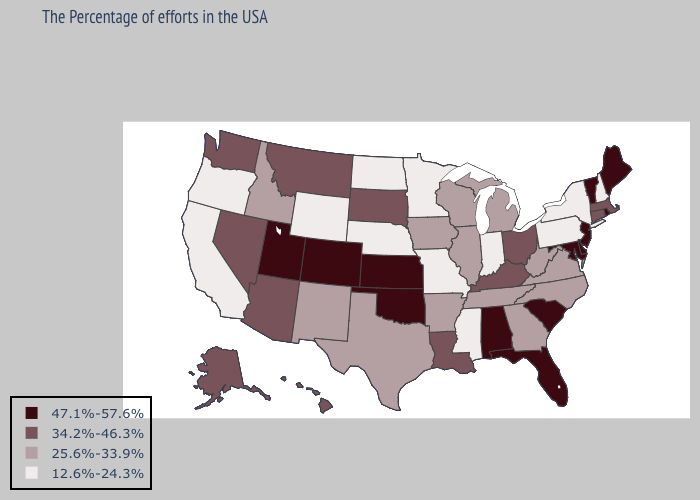Is the legend a continuous bar?
Write a very short answer. No. Does the map have missing data?
Give a very brief answer. No. Does Iowa have a higher value than Indiana?
Short answer required. Yes. Does Hawaii have a higher value than Missouri?
Short answer required. Yes. Which states hav the highest value in the Northeast?
Answer briefly. Maine, Rhode Island, Vermont, New Jersey. Does Kansas have the same value as Delaware?
Write a very short answer. Yes. Which states have the lowest value in the South?
Keep it brief. Mississippi. Does Nebraska have the highest value in the MidWest?
Answer briefly. No. Which states have the lowest value in the USA?
Keep it brief. New Hampshire, New York, Pennsylvania, Indiana, Mississippi, Missouri, Minnesota, Nebraska, North Dakota, Wyoming, California, Oregon. Among the states that border Ohio , does Pennsylvania have the lowest value?
Give a very brief answer. Yes. Does North Carolina have a higher value than Wyoming?
Write a very short answer. Yes. Which states have the lowest value in the South?
Give a very brief answer. Mississippi. Name the states that have a value in the range 25.6%-33.9%?
Short answer required. Virginia, North Carolina, West Virginia, Georgia, Michigan, Tennessee, Wisconsin, Illinois, Arkansas, Iowa, Texas, New Mexico, Idaho. What is the lowest value in states that border Montana?
Answer briefly. 12.6%-24.3%. What is the value of Tennessee?
Concise answer only. 25.6%-33.9%. 